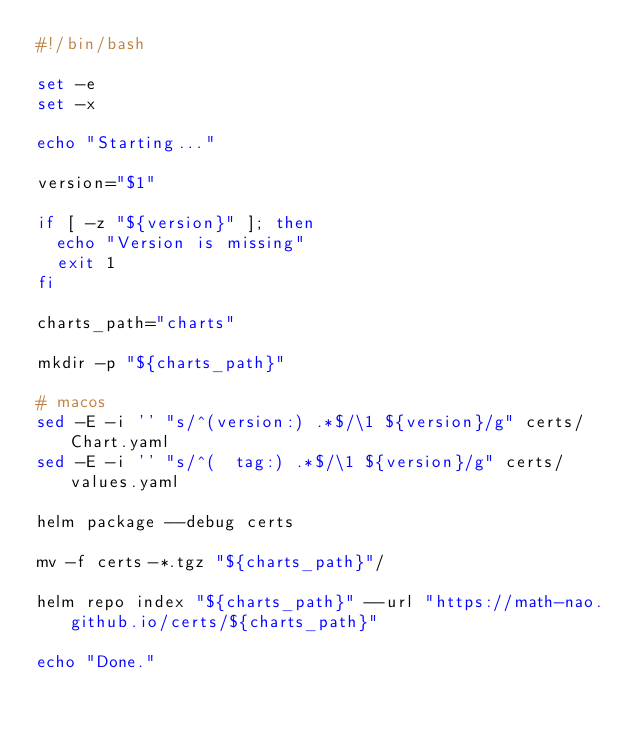<code> <loc_0><loc_0><loc_500><loc_500><_Bash_>#!/bin/bash

set -e
set -x

echo "Starting..."

version="$1"

if [ -z "${version}" ]; then
  echo "Version is missing"
  exit 1
fi

charts_path="charts"

mkdir -p "${charts_path}"

# macos
sed -E -i '' "s/^(version:) .*$/\1 ${version}/g" certs/Chart.yaml
sed -E -i '' "s/^(  tag:) .*$/\1 ${version}/g" certs/values.yaml

helm package --debug certs

mv -f certs-*.tgz "${charts_path}"/

helm repo index "${charts_path}" --url "https://math-nao.github.io/certs/${charts_path}"

echo "Done."</code> 